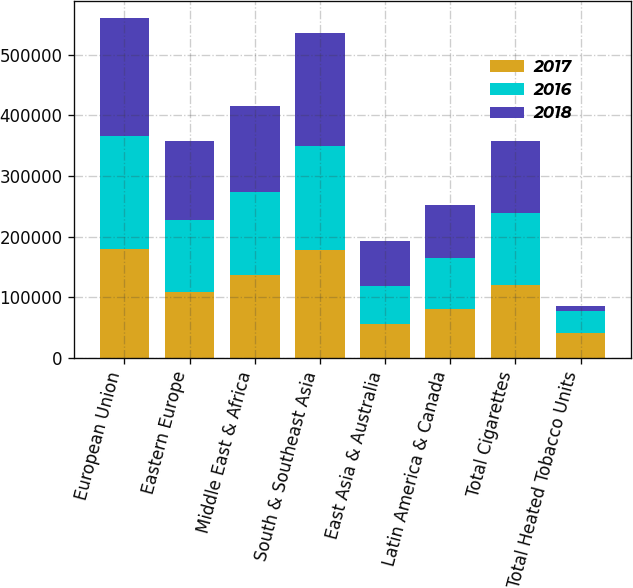Convert chart to OTSL. <chart><loc_0><loc_0><loc_500><loc_500><stacked_bar_chart><ecel><fcel>European Union<fcel>Eastern Europe<fcel>Middle East & Africa<fcel>South & Southeast Asia<fcel>East Asia & Australia<fcel>Latin America & Canada<fcel>Total Cigarettes<fcel>Total Heated Tobacco Units<nl><fcel>2017<fcel>179622<fcel>108718<fcel>136605<fcel>178469<fcel>56163<fcel>80738<fcel>119398<fcel>41372<nl><fcel>2016<fcel>187293<fcel>119398<fcel>136759<fcel>171600<fcel>62653<fcel>84223<fcel>119398<fcel>36226<nl><fcel>2018<fcel>193586<fcel>129456<fcel>141937<fcel>185279<fcel>74750<fcel>87938<fcel>119398<fcel>7394<nl></chart> 